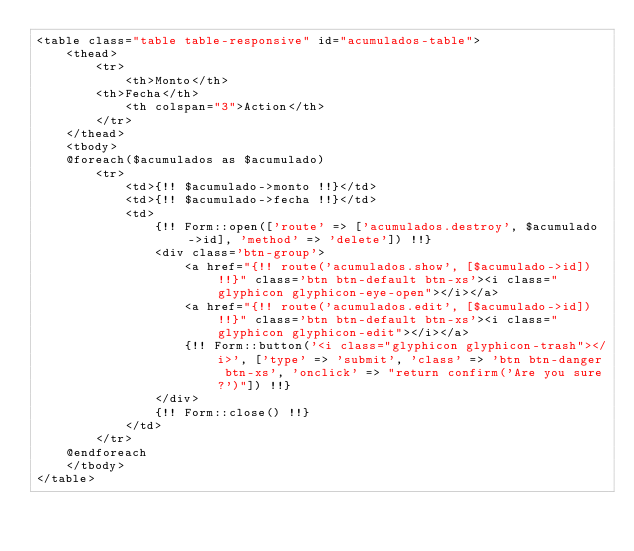<code> <loc_0><loc_0><loc_500><loc_500><_PHP_><table class="table table-responsive" id="acumulados-table">
    <thead>
        <tr>
            <th>Monto</th>
        <th>Fecha</th>
            <th colspan="3">Action</th>
        </tr>
    </thead>
    <tbody>
    @foreach($acumulados as $acumulado)
        <tr>
            <td>{!! $acumulado->monto !!}</td>
            <td>{!! $acumulado->fecha !!}</td>
            <td>
                {!! Form::open(['route' => ['acumulados.destroy', $acumulado->id], 'method' => 'delete']) !!}
                <div class='btn-group'>
                    <a href="{!! route('acumulados.show', [$acumulado->id]) !!}" class='btn btn-default btn-xs'><i class="glyphicon glyphicon-eye-open"></i></a>
                    <a href="{!! route('acumulados.edit', [$acumulado->id]) !!}" class='btn btn-default btn-xs'><i class="glyphicon glyphicon-edit"></i></a>
                    {!! Form::button('<i class="glyphicon glyphicon-trash"></i>', ['type' => 'submit', 'class' => 'btn btn-danger btn-xs', 'onclick' => "return confirm('Are you sure?')"]) !!}
                </div>
                {!! Form::close() !!}
            </td>
        </tr>
    @endforeach
    </tbody>
</table></code> 